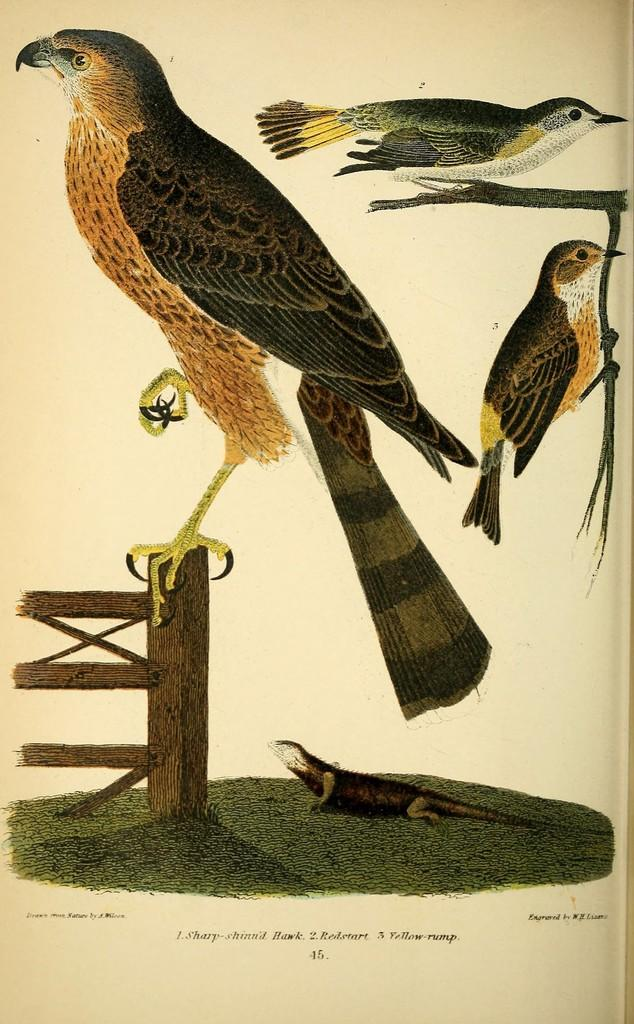What is the main subject of the image? The main subject of the image is a picture of birds. Where are the birds located in the image? The birds are standing on branches in the image. What other animal can be seen in the image? There is a reptile visible in the image. On what surface is the reptile located? The reptile is on the grass in the image. What is the range of the birds' flight in the image? The image does not show the birds in flight, so their range cannot be determined. 